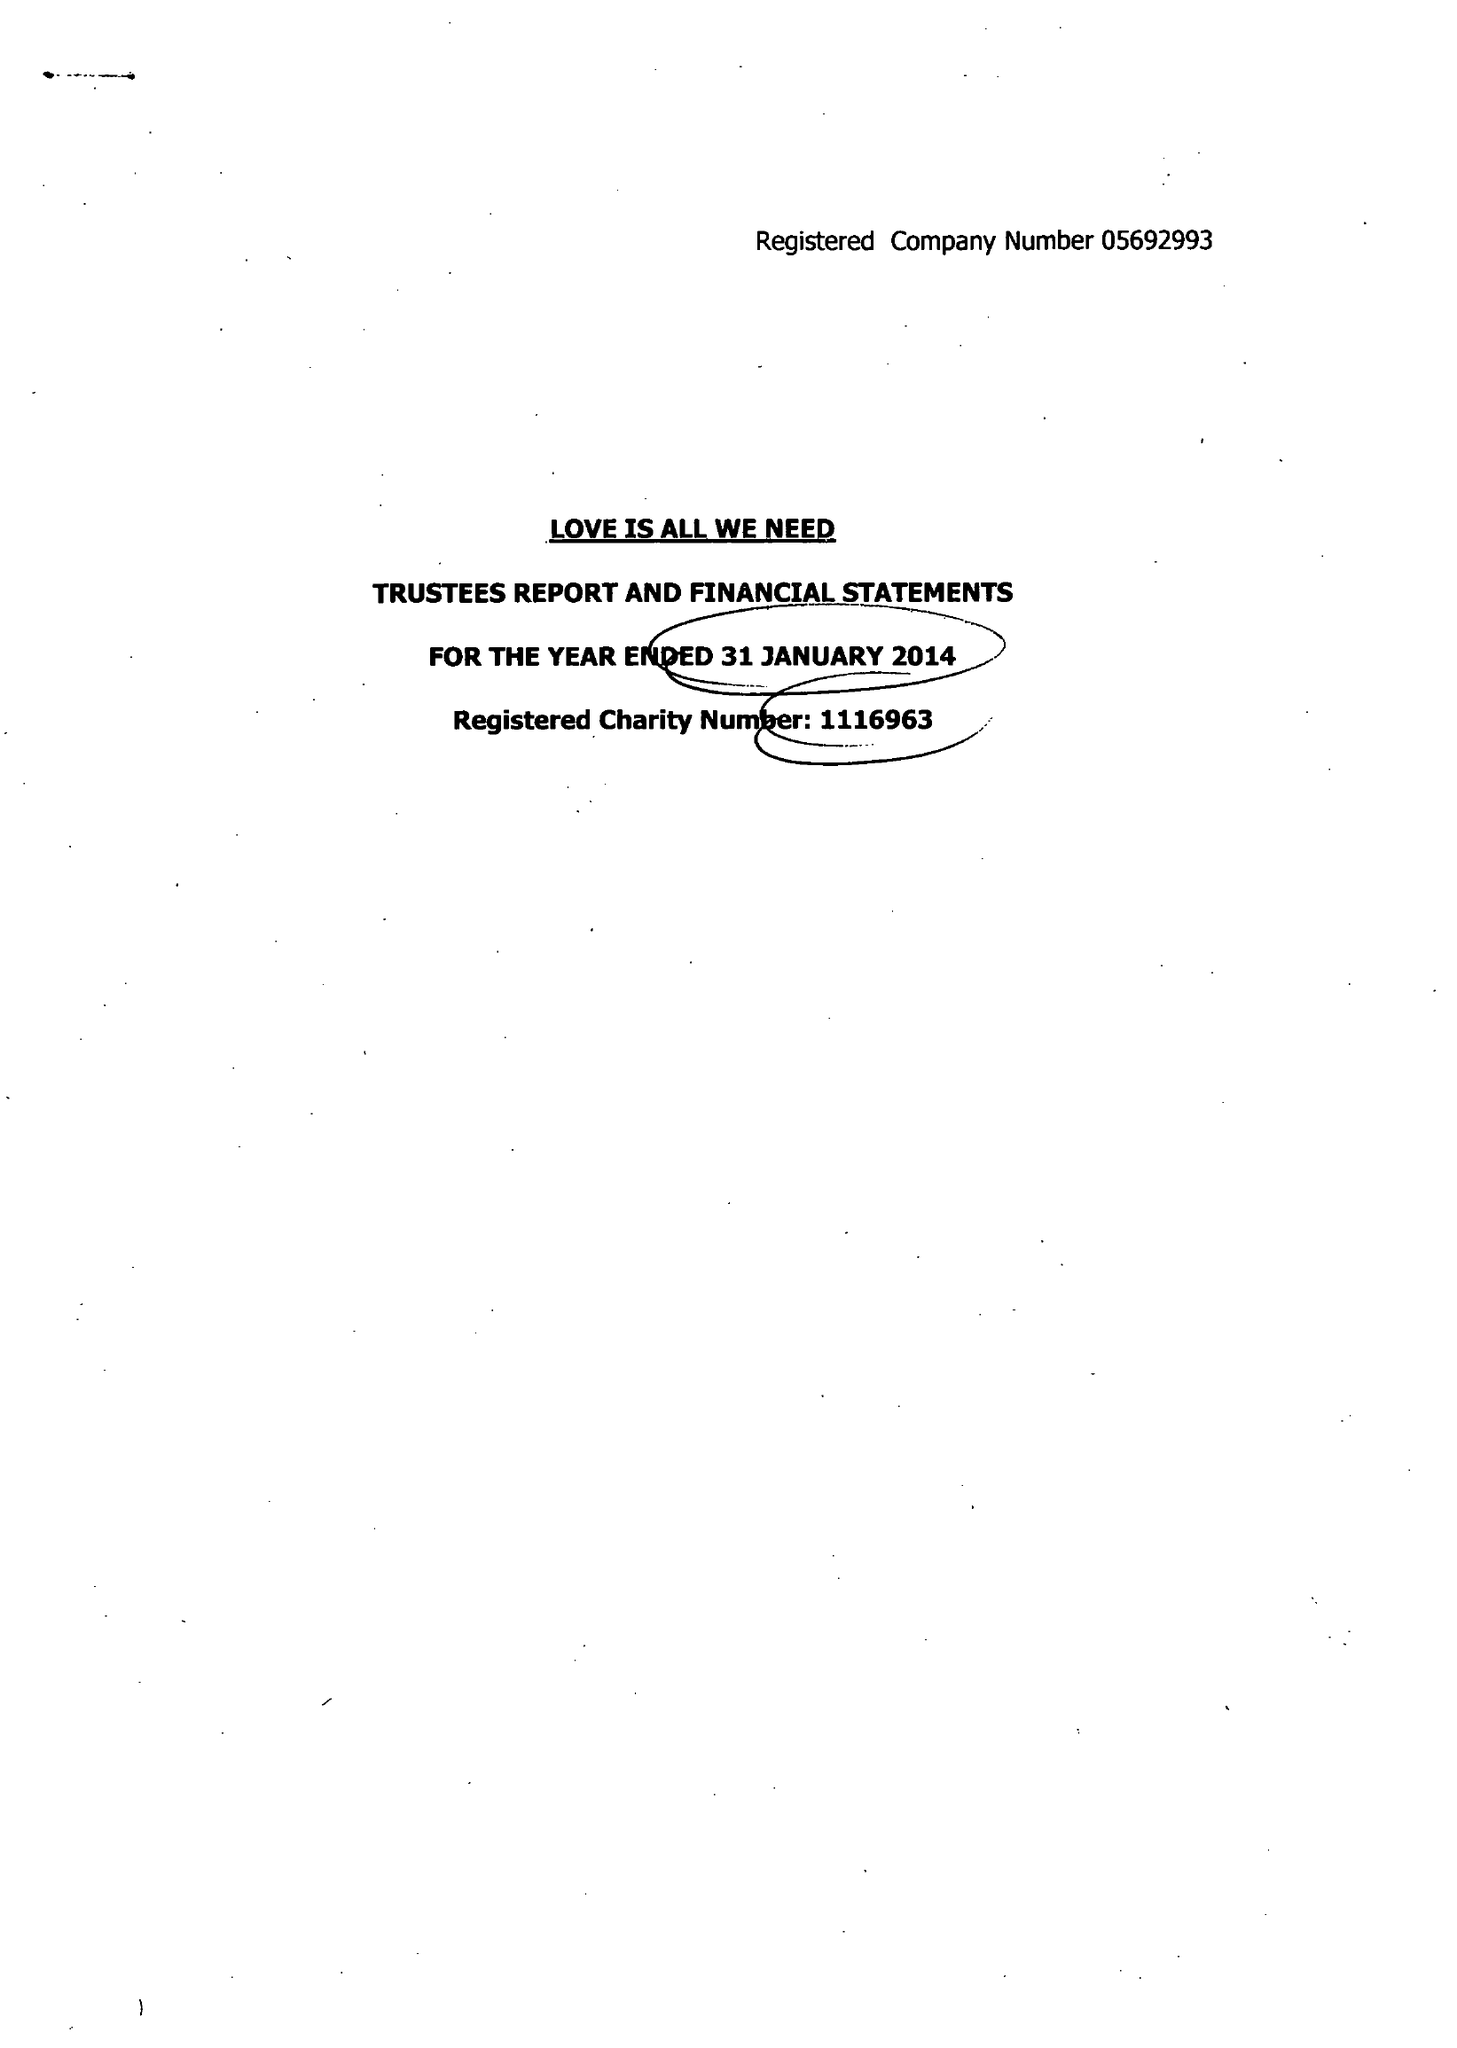What is the value for the charity_name?
Answer the question using a single word or phrase. Love Is All We Need 